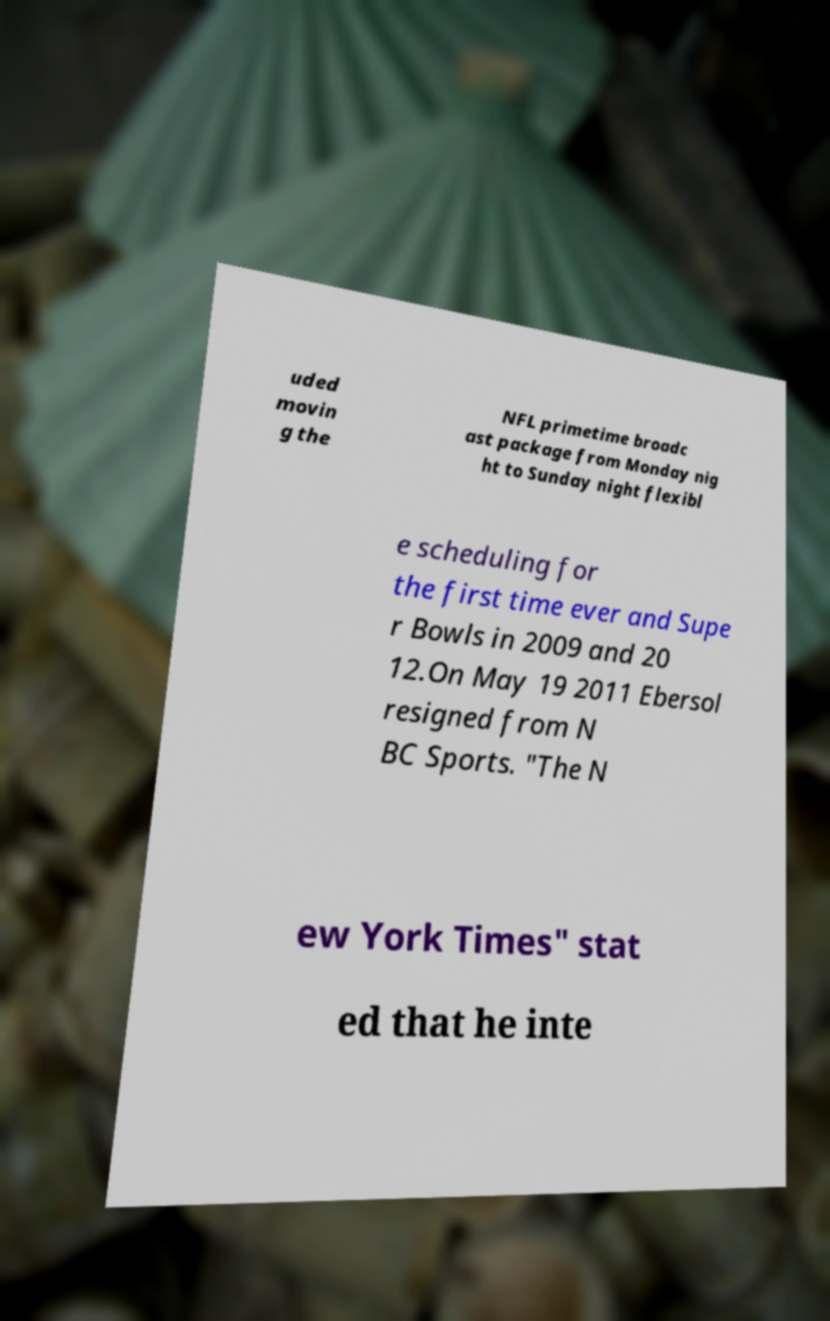What messages or text are displayed in this image? I need them in a readable, typed format. uded movin g the NFL primetime broadc ast package from Monday nig ht to Sunday night flexibl e scheduling for the first time ever and Supe r Bowls in 2009 and 20 12.On May 19 2011 Ebersol resigned from N BC Sports. "The N ew York Times" stat ed that he inte 